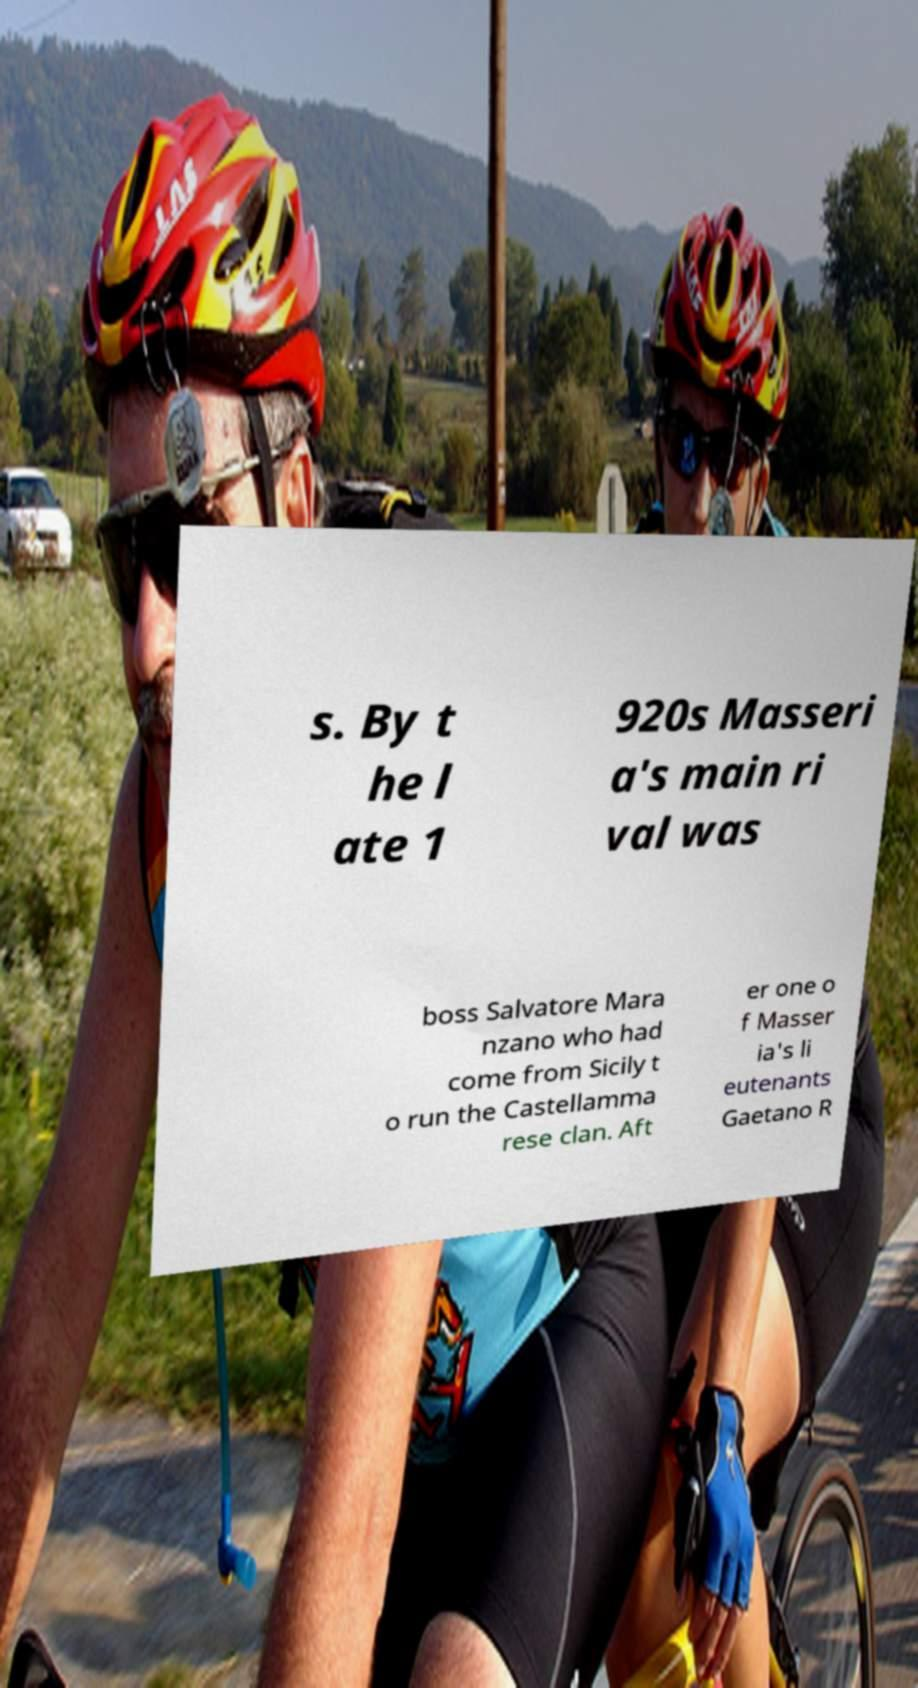Please read and relay the text visible in this image. What does it say? s. By t he l ate 1 920s Masseri a's main ri val was boss Salvatore Mara nzano who had come from Sicily t o run the Castellamma rese clan. Aft er one o f Masser ia's li eutenants Gaetano R 